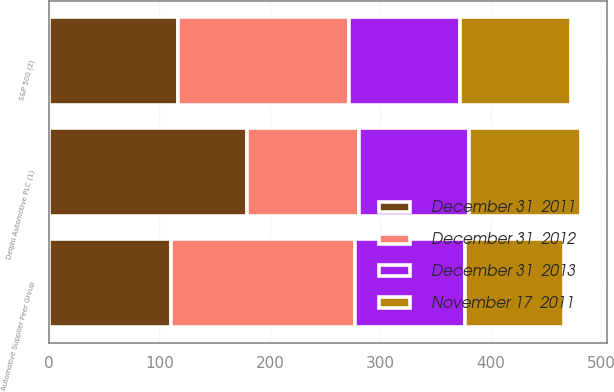<chart> <loc_0><loc_0><loc_500><loc_500><stacked_bar_chart><ecel><fcel>Delphi Automotive PLC (1)<fcel>S&P 500 (2)<fcel>Automotive Supplier Peer Group<nl><fcel>December 31  2013<fcel>100<fcel>100<fcel>100<nl><fcel>November 17  2011<fcel>100.98<fcel>100.8<fcel>89.27<nl><fcel>December 31  2011<fcel>179.33<fcel>116.93<fcel>110.41<nl><fcel>December 31  2012<fcel>100.98<fcel>154.8<fcel>166.46<nl></chart> 